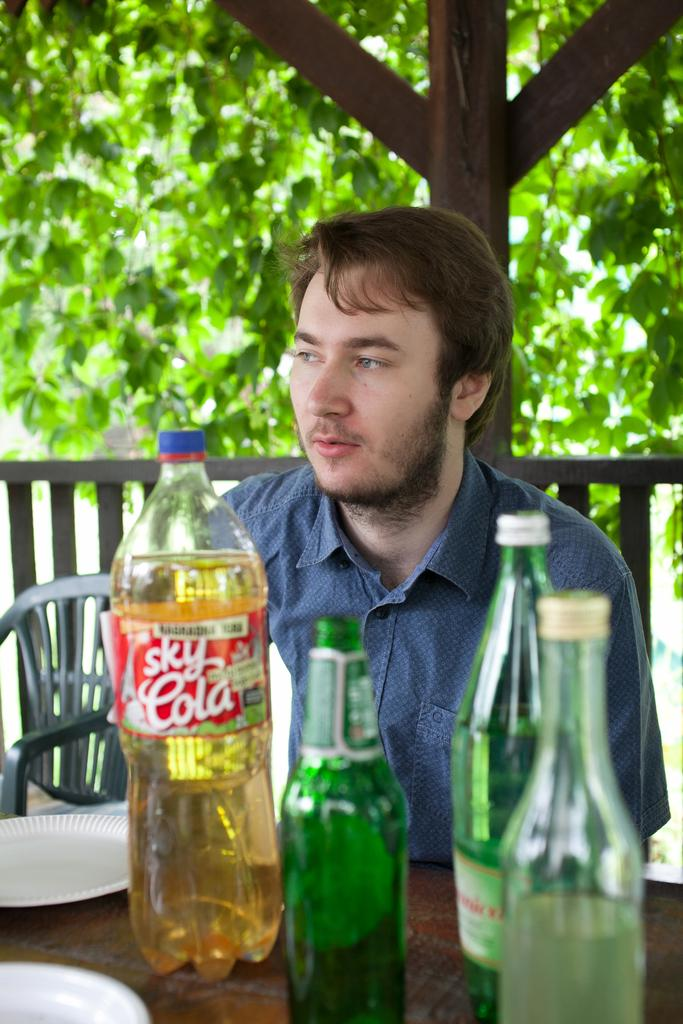<image>
Offer a succinct explanation of the picture presented. Man sitting outdoors with a bottle of Sky Cola in front of him. 